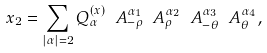<formula> <loc_0><loc_0><loc_500><loc_500>x _ { 2 } = \sum _ { | \alpha | = 2 } Q _ { \alpha } ^ { ( x ) } \ A _ { - \rho } ^ { \alpha _ { 1 } } \ A _ { \rho } ^ { \alpha _ { 2 } } \ A _ { - \theta } ^ { \alpha _ { 3 } } \ A _ { \theta } ^ { \alpha _ { 4 } } ,</formula> 